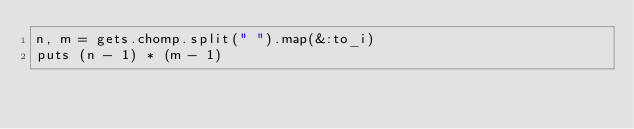<code> <loc_0><loc_0><loc_500><loc_500><_Ruby_>n, m = gets.chomp.split(" ").map(&:to_i)
puts (n - 1) * (m - 1)
</code> 